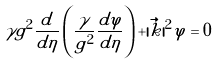<formula> <loc_0><loc_0><loc_500><loc_500>\gamma g ^ { 2 } \frac { d } { d \eta } \left ( \frac { \gamma } { g ^ { 2 } } \frac { d \varphi } { d \eta } \right ) + | \vec { k } | ^ { 2 } \varphi = 0</formula> 